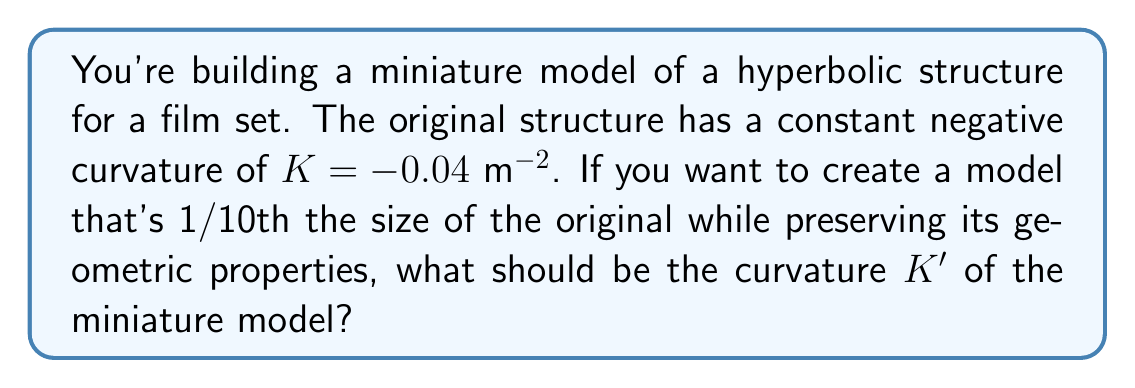Could you help me with this problem? To solve this problem, we need to understand how scaling affects the curvature of a non-Euclidean structure. In hyperbolic geometry, curvature scales inversely with the square of the scaling factor. Let's approach this step-by-step:

1) Let's define our scaling factor:
   $s = \frac{1}{10}$ (since we're making the model 1/10th the size)

2) The relationship between the original curvature $K$ and the new curvature $K'$ is:
   $K' = \frac{K}{s^2}$

3) We know:
   $K = -0.04$ $\text{m}^{-2}$
   $s = \frac{1}{10} = 0.1$

4) Let's substitute these values into our equation:
   $K' = \frac{-0.04}{(0.1)^2}$

5) Simplify:
   $K' = \frac{-0.04}{0.01} = -4$ $\text{m}^{-2}$

Therefore, to preserve the geometric properties of the original hyperbolic structure in a 1/10th scale model, the curvature of the miniature model should be -4 $\text{m}^{-2}$.
Answer: $-4$ $\text{m}^{-2}$ 